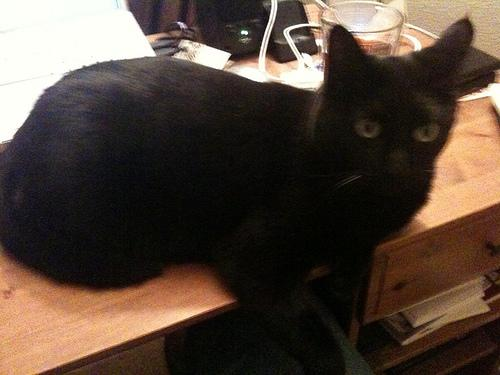What emotion does the cat appear to be expressing?

Choices:
A) disgust
B) love
C) excitement
D) surprise surprise 